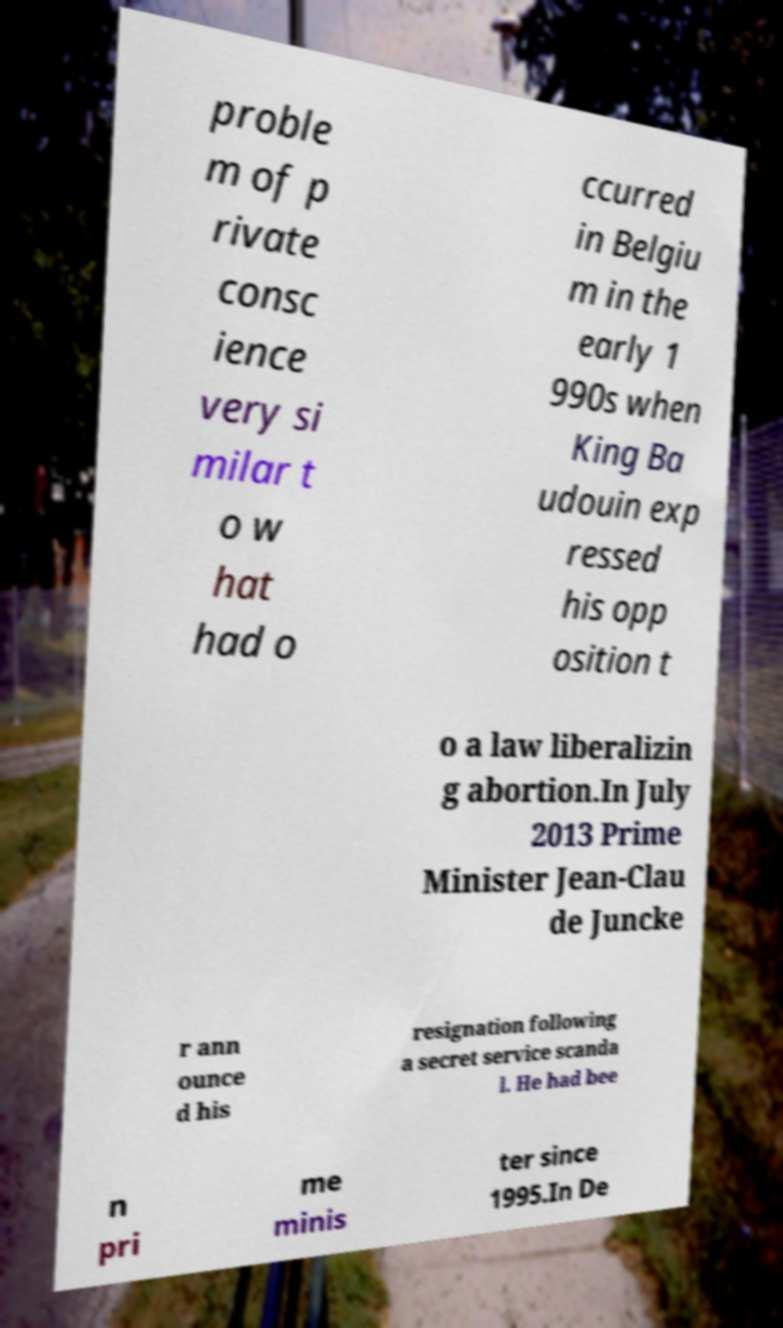Can you read and provide the text displayed in the image?This photo seems to have some interesting text. Can you extract and type it out for me? proble m of p rivate consc ience very si milar t o w hat had o ccurred in Belgiu m in the early 1 990s when King Ba udouin exp ressed his opp osition t o a law liberalizin g abortion.In July 2013 Prime Minister Jean-Clau de Juncke r ann ounce d his resignation following a secret service scanda l. He had bee n pri me minis ter since 1995.In De 